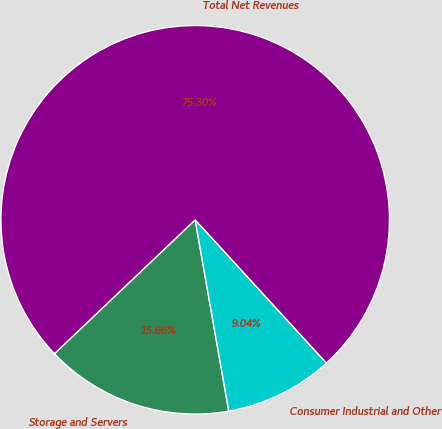Convert chart to OTSL. <chart><loc_0><loc_0><loc_500><loc_500><pie_chart><fcel>Storage and Servers<fcel>Consumer Industrial and Other<fcel>Total Net Revenues<nl><fcel>15.66%<fcel>9.04%<fcel>75.3%<nl></chart> 